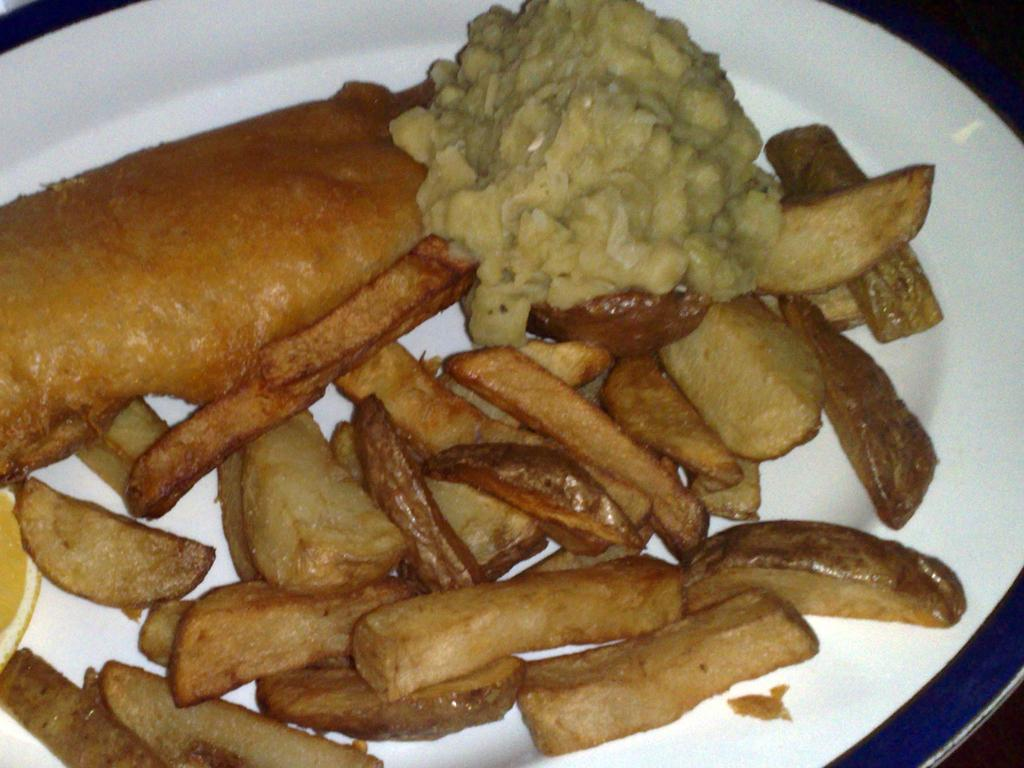What is on the plate that is visible in the image? There is a white plate in the image, and it has wedges on it. What else can be seen on the plate besides the wedges? There are other food items on the plate. How does the snow affect the duck on the plate in the image? There is no snow or duck present on the plate in the image. 